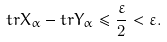<formula> <loc_0><loc_0><loc_500><loc_500>t r X _ { \alpha } - t r Y _ { \alpha } \leq \frac { \varepsilon } 2 < \varepsilon .</formula> 